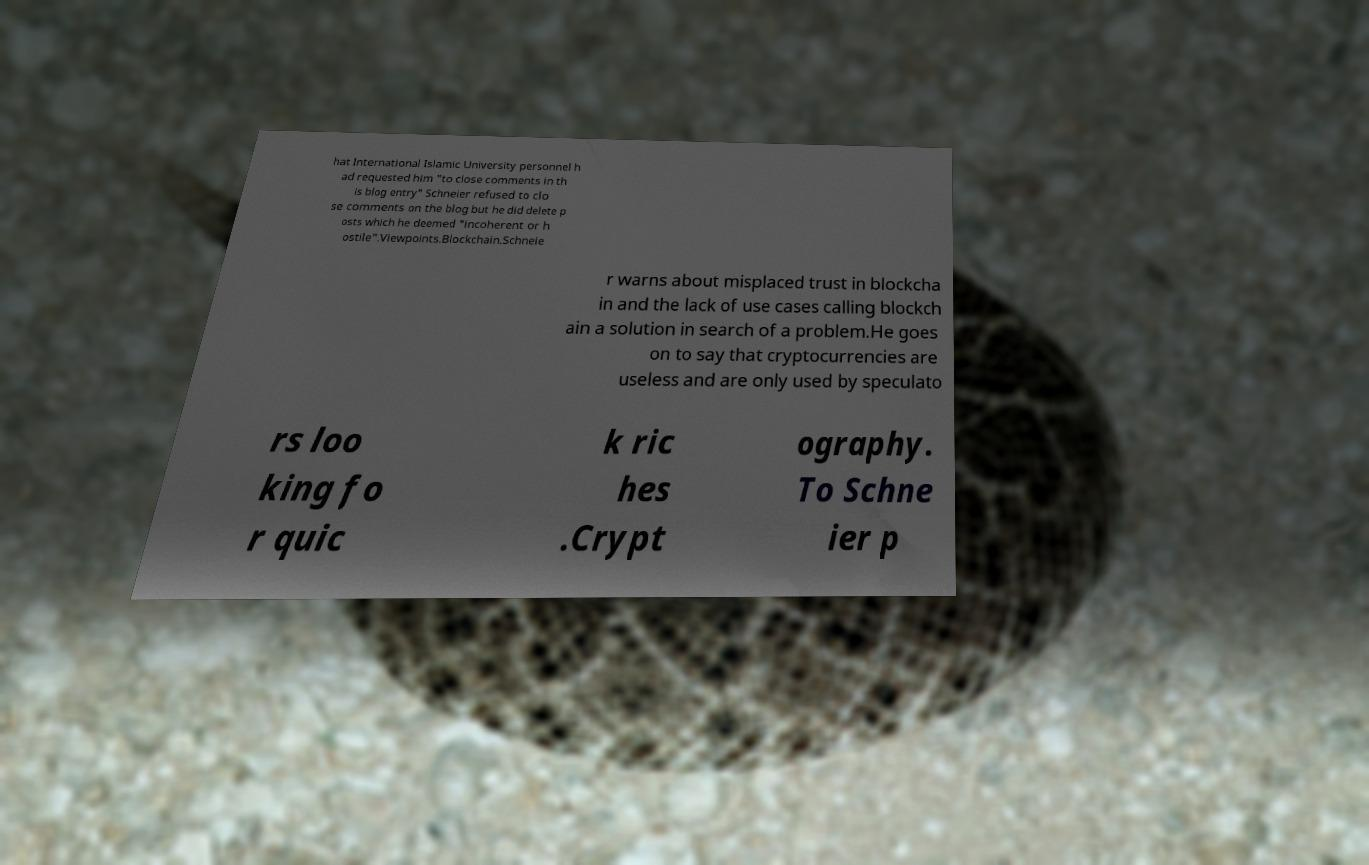Could you extract and type out the text from this image? hat International Islamic University personnel h ad requested him "to close comments in th is blog entry" Schneier refused to clo se comments on the blog but he did delete p osts which he deemed "incoherent or h ostile".Viewpoints.Blockchain.Schneie r warns about misplaced trust in blockcha in and the lack of use cases calling blockch ain a solution in search of a problem.He goes on to say that cryptocurrencies are useless and are only used by speculato rs loo king fo r quic k ric hes .Crypt ography. To Schne ier p 